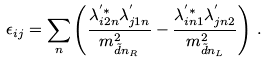Convert formula to latex. <formula><loc_0><loc_0><loc_500><loc_500>\epsilon _ { i j } = \sum _ { n } \left ( \frac { \lambda _ { i 2 n } ^ { ^ { \prime } * } \lambda _ { j 1 n } ^ { ^ { \prime } } } { m _ { \tilde { d } n _ { R } } ^ { 2 } } - \frac { \lambda _ { i n 1 } ^ { ^ { \prime } * } \lambda _ { j n 2 } ^ { ^ { \prime } } } { m _ { \tilde { d } n _ { L } } ^ { 2 } } \right ) \, .</formula> 